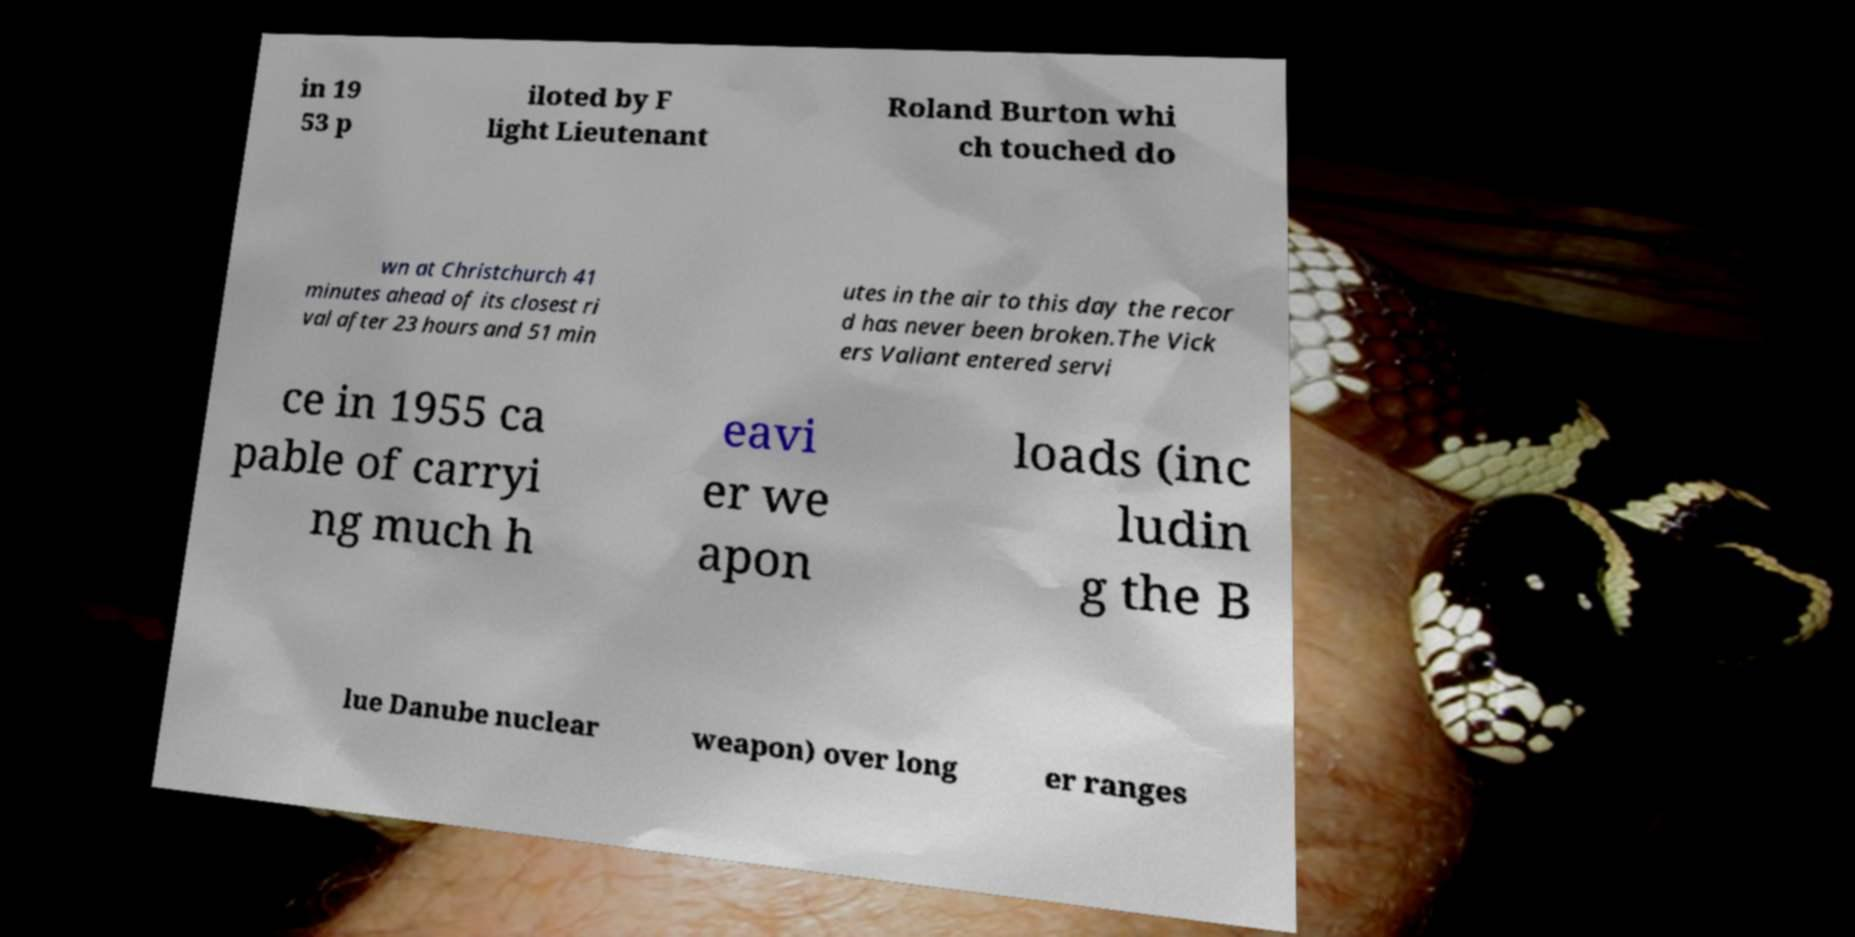Please read and relay the text visible in this image. What does it say? in 19 53 p iloted by F light Lieutenant Roland Burton whi ch touched do wn at Christchurch 41 minutes ahead of its closest ri val after 23 hours and 51 min utes in the air to this day the recor d has never been broken.The Vick ers Valiant entered servi ce in 1955 ca pable of carryi ng much h eavi er we apon loads (inc ludin g the B lue Danube nuclear weapon) over long er ranges 